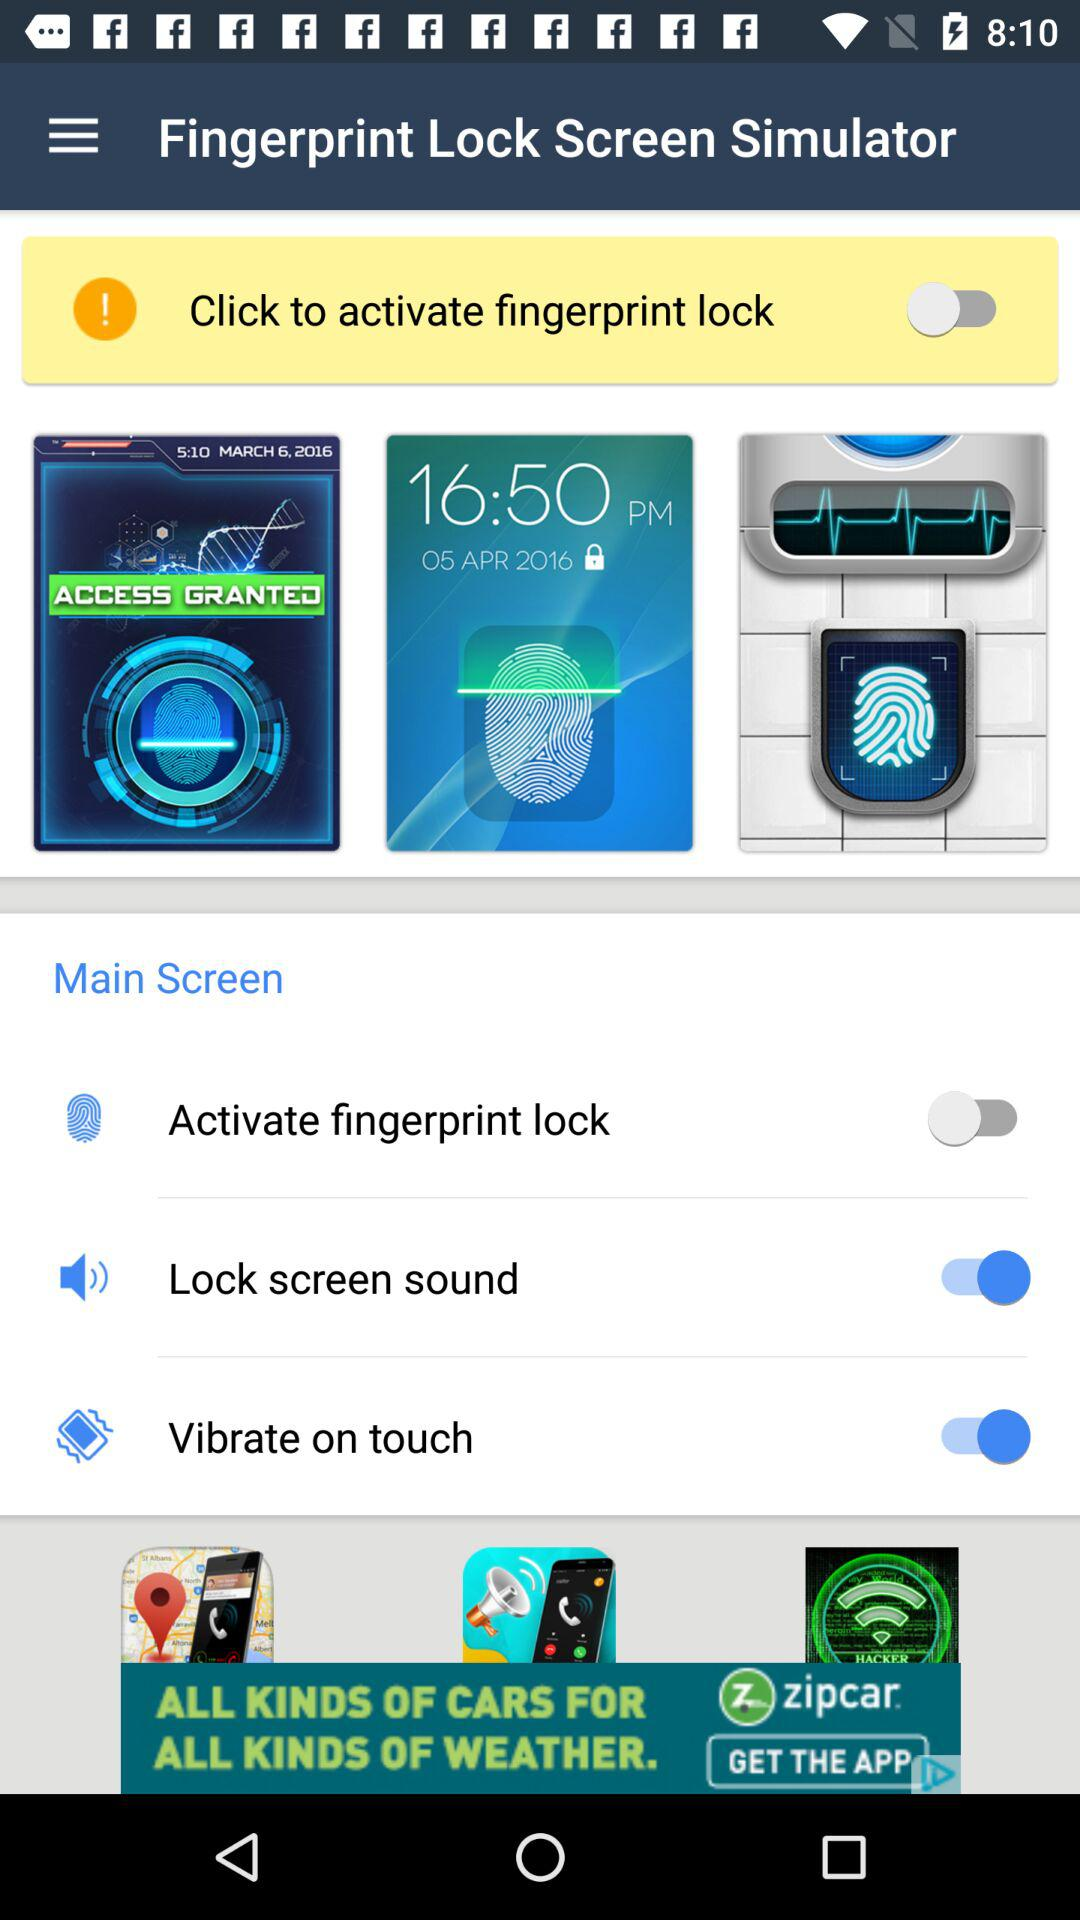What are the options given in the main screen? The options are "Activate fingerprint lock", "Lock screen sound" and "Vibrate on touch". 